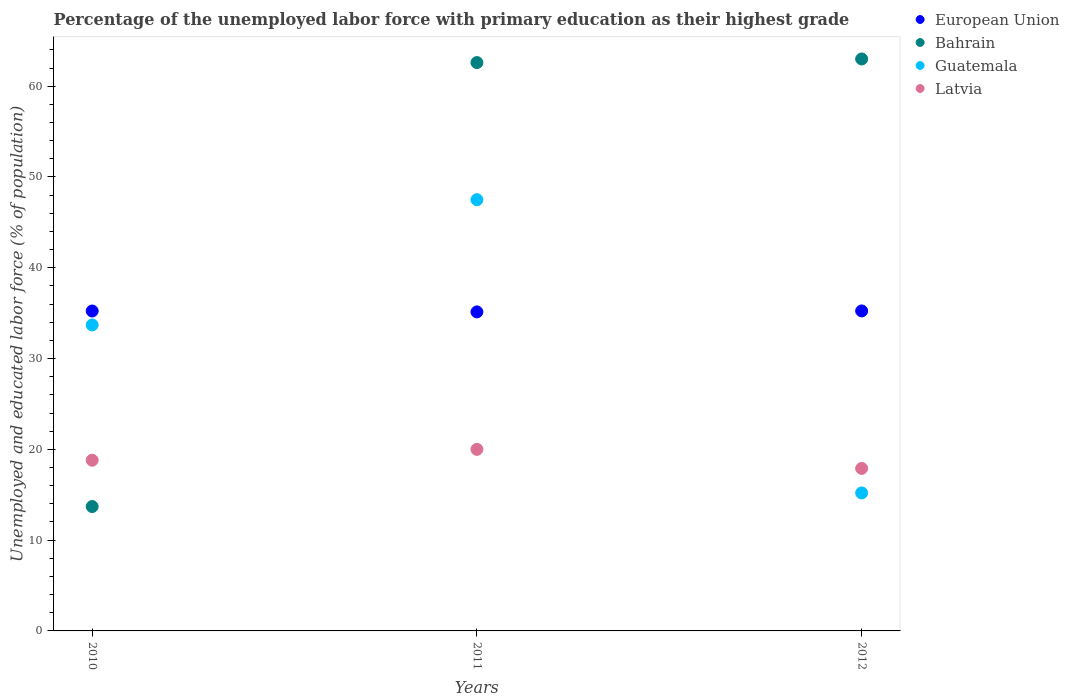Is the number of dotlines equal to the number of legend labels?
Your response must be concise. Yes. Across all years, what is the maximum percentage of the unemployed labor force with primary education in Guatemala?
Keep it short and to the point. 47.5. Across all years, what is the minimum percentage of the unemployed labor force with primary education in Bahrain?
Keep it short and to the point. 13.7. In which year was the percentage of the unemployed labor force with primary education in European Union maximum?
Make the answer very short. 2012. In which year was the percentage of the unemployed labor force with primary education in Latvia minimum?
Provide a succinct answer. 2012. What is the total percentage of the unemployed labor force with primary education in European Union in the graph?
Your answer should be very brief. 105.62. What is the difference between the percentage of the unemployed labor force with primary education in Bahrain in 2010 and that in 2011?
Offer a terse response. -48.9. What is the difference between the percentage of the unemployed labor force with primary education in Guatemala in 2011 and the percentage of the unemployed labor force with primary education in European Union in 2012?
Your answer should be very brief. 12.25. What is the average percentage of the unemployed labor force with primary education in Guatemala per year?
Your answer should be compact. 32.13. In the year 2011, what is the difference between the percentage of the unemployed labor force with primary education in Bahrain and percentage of the unemployed labor force with primary education in Latvia?
Make the answer very short. 42.6. In how many years, is the percentage of the unemployed labor force with primary education in Guatemala greater than 12 %?
Your response must be concise. 3. What is the ratio of the percentage of the unemployed labor force with primary education in Latvia in 2010 to that in 2011?
Your answer should be compact. 0.94. Is the difference between the percentage of the unemployed labor force with primary education in Bahrain in 2011 and 2012 greater than the difference between the percentage of the unemployed labor force with primary education in Latvia in 2011 and 2012?
Provide a succinct answer. No. What is the difference between the highest and the second highest percentage of the unemployed labor force with primary education in Bahrain?
Your answer should be very brief. 0.4. What is the difference between the highest and the lowest percentage of the unemployed labor force with primary education in Guatemala?
Make the answer very short. 32.3. Is the sum of the percentage of the unemployed labor force with primary education in Bahrain in 2011 and 2012 greater than the maximum percentage of the unemployed labor force with primary education in European Union across all years?
Ensure brevity in your answer.  Yes. Is it the case that in every year, the sum of the percentage of the unemployed labor force with primary education in Bahrain and percentage of the unemployed labor force with primary education in European Union  is greater than the percentage of the unemployed labor force with primary education in Guatemala?
Keep it short and to the point. Yes. Is the percentage of the unemployed labor force with primary education in Latvia strictly greater than the percentage of the unemployed labor force with primary education in European Union over the years?
Make the answer very short. No. Is the percentage of the unemployed labor force with primary education in Bahrain strictly less than the percentage of the unemployed labor force with primary education in Guatemala over the years?
Your response must be concise. No. Does the graph contain any zero values?
Make the answer very short. No. How are the legend labels stacked?
Keep it short and to the point. Vertical. What is the title of the graph?
Keep it short and to the point. Percentage of the unemployed labor force with primary education as their highest grade. Does "World" appear as one of the legend labels in the graph?
Offer a terse response. No. What is the label or title of the Y-axis?
Ensure brevity in your answer.  Unemployed and educated labor force (% of population). What is the Unemployed and educated labor force (% of population) of European Union in 2010?
Your response must be concise. 35.24. What is the Unemployed and educated labor force (% of population) in Bahrain in 2010?
Your response must be concise. 13.7. What is the Unemployed and educated labor force (% of population) in Guatemala in 2010?
Offer a terse response. 33.7. What is the Unemployed and educated labor force (% of population) in Latvia in 2010?
Offer a terse response. 18.8. What is the Unemployed and educated labor force (% of population) in European Union in 2011?
Give a very brief answer. 35.14. What is the Unemployed and educated labor force (% of population) in Bahrain in 2011?
Provide a short and direct response. 62.6. What is the Unemployed and educated labor force (% of population) in Guatemala in 2011?
Provide a short and direct response. 47.5. What is the Unemployed and educated labor force (% of population) of European Union in 2012?
Your answer should be very brief. 35.25. What is the Unemployed and educated labor force (% of population) in Bahrain in 2012?
Your answer should be very brief. 63. What is the Unemployed and educated labor force (% of population) of Guatemala in 2012?
Ensure brevity in your answer.  15.2. What is the Unemployed and educated labor force (% of population) in Latvia in 2012?
Make the answer very short. 17.9. Across all years, what is the maximum Unemployed and educated labor force (% of population) of European Union?
Keep it short and to the point. 35.25. Across all years, what is the maximum Unemployed and educated labor force (% of population) in Bahrain?
Provide a succinct answer. 63. Across all years, what is the maximum Unemployed and educated labor force (% of population) in Guatemala?
Keep it short and to the point. 47.5. Across all years, what is the maximum Unemployed and educated labor force (% of population) of Latvia?
Provide a short and direct response. 20. Across all years, what is the minimum Unemployed and educated labor force (% of population) in European Union?
Your answer should be compact. 35.14. Across all years, what is the minimum Unemployed and educated labor force (% of population) of Bahrain?
Provide a succinct answer. 13.7. Across all years, what is the minimum Unemployed and educated labor force (% of population) of Guatemala?
Make the answer very short. 15.2. Across all years, what is the minimum Unemployed and educated labor force (% of population) of Latvia?
Offer a very short reply. 17.9. What is the total Unemployed and educated labor force (% of population) in European Union in the graph?
Ensure brevity in your answer.  105.62. What is the total Unemployed and educated labor force (% of population) in Bahrain in the graph?
Give a very brief answer. 139.3. What is the total Unemployed and educated labor force (% of population) of Guatemala in the graph?
Provide a short and direct response. 96.4. What is the total Unemployed and educated labor force (% of population) in Latvia in the graph?
Your answer should be compact. 56.7. What is the difference between the Unemployed and educated labor force (% of population) of European Union in 2010 and that in 2011?
Your response must be concise. 0.1. What is the difference between the Unemployed and educated labor force (% of population) in Bahrain in 2010 and that in 2011?
Your answer should be very brief. -48.9. What is the difference between the Unemployed and educated labor force (% of population) of European Union in 2010 and that in 2012?
Provide a short and direct response. -0.01. What is the difference between the Unemployed and educated labor force (% of population) in Bahrain in 2010 and that in 2012?
Make the answer very short. -49.3. What is the difference between the Unemployed and educated labor force (% of population) of Guatemala in 2010 and that in 2012?
Provide a succinct answer. 18.5. What is the difference between the Unemployed and educated labor force (% of population) in European Union in 2011 and that in 2012?
Your answer should be compact. -0.11. What is the difference between the Unemployed and educated labor force (% of population) in Bahrain in 2011 and that in 2012?
Provide a succinct answer. -0.4. What is the difference between the Unemployed and educated labor force (% of population) of Guatemala in 2011 and that in 2012?
Offer a terse response. 32.3. What is the difference between the Unemployed and educated labor force (% of population) of Latvia in 2011 and that in 2012?
Ensure brevity in your answer.  2.1. What is the difference between the Unemployed and educated labor force (% of population) of European Union in 2010 and the Unemployed and educated labor force (% of population) of Bahrain in 2011?
Keep it short and to the point. -27.36. What is the difference between the Unemployed and educated labor force (% of population) of European Union in 2010 and the Unemployed and educated labor force (% of population) of Guatemala in 2011?
Make the answer very short. -12.26. What is the difference between the Unemployed and educated labor force (% of population) of European Union in 2010 and the Unemployed and educated labor force (% of population) of Latvia in 2011?
Provide a short and direct response. 15.24. What is the difference between the Unemployed and educated labor force (% of population) of Bahrain in 2010 and the Unemployed and educated labor force (% of population) of Guatemala in 2011?
Offer a very short reply. -33.8. What is the difference between the Unemployed and educated labor force (% of population) of European Union in 2010 and the Unemployed and educated labor force (% of population) of Bahrain in 2012?
Keep it short and to the point. -27.76. What is the difference between the Unemployed and educated labor force (% of population) in European Union in 2010 and the Unemployed and educated labor force (% of population) in Guatemala in 2012?
Your answer should be very brief. 20.04. What is the difference between the Unemployed and educated labor force (% of population) in European Union in 2010 and the Unemployed and educated labor force (% of population) in Latvia in 2012?
Provide a short and direct response. 17.34. What is the difference between the Unemployed and educated labor force (% of population) of Guatemala in 2010 and the Unemployed and educated labor force (% of population) of Latvia in 2012?
Your answer should be very brief. 15.8. What is the difference between the Unemployed and educated labor force (% of population) of European Union in 2011 and the Unemployed and educated labor force (% of population) of Bahrain in 2012?
Give a very brief answer. -27.86. What is the difference between the Unemployed and educated labor force (% of population) of European Union in 2011 and the Unemployed and educated labor force (% of population) of Guatemala in 2012?
Give a very brief answer. 19.94. What is the difference between the Unemployed and educated labor force (% of population) of European Union in 2011 and the Unemployed and educated labor force (% of population) of Latvia in 2012?
Your answer should be compact. 17.24. What is the difference between the Unemployed and educated labor force (% of population) of Bahrain in 2011 and the Unemployed and educated labor force (% of population) of Guatemala in 2012?
Offer a terse response. 47.4. What is the difference between the Unemployed and educated labor force (% of population) in Bahrain in 2011 and the Unemployed and educated labor force (% of population) in Latvia in 2012?
Ensure brevity in your answer.  44.7. What is the difference between the Unemployed and educated labor force (% of population) in Guatemala in 2011 and the Unemployed and educated labor force (% of population) in Latvia in 2012?
Make the answer very short. 29.6. What is the average Unemployed and educated labor force (% of population) in European Union per year?
Make the answer very short. 35.21. What is the average Unemployed and educated labor force (% of population) in Bahrain per year?
Provide a short and direct response. 46.43. What is the average Unemployed and educated labor force (% of population) of Guatemala per year?
Give a very brief answer. 32.13. In the year 2010, what is the difference between the Unemployed and educated labor force (% of population) of European Union and Unemployed and educated labor force (% of population) of Bahrain?
Offer a very short reply. 21.54. In the year 2010, what is the difference between the Unemployed and educated labor force (% of population) in European Union and Unemployed and educated labor force (% of population) in Guatemala?
Make the answer very short. 1.54. In the year 2010, what is the difference between the Unemployed and educated labor force (% of population) of European Union and Unemployed and educated labor force (% of population) of Latvia?
Your answer should be very brief. 16.44. In the year 2010, what is the difference between the Unemployed and educated labor force (% of population) of Bahrain and Unemployed and educated labor force (% of population) of Guatemala?
Provide a succinct answer. -20. In the year 2010, what is the difference between the Unemployed and educated labor force (% of population) in Bahrain and Unemployed and educated labor force (% of population) in Latvia?
Provide a succinct answer. -5.1. In the year 2010, what is the difference between the Unemployed and educated labor force (% of population) in Guatemala and Unemployed and educated labor force (% of population) in Latvia?
Your answer should be compact. 14.9. In the year 2011, what is the difference between the Unemployed and educated labor force (% of population) of European Union and Unemployed and educated labor force (% of population) of Bahrain?
Your response must be concise. -27.46. In the year 2011, what is the difference between the Unemployed and educated labor force (% of population) of European Union and Unemployed and educated labor force (% of population) of Guatemala?
Provide a succinct answer. -12.36. In the year 2011, what is the difference between the Unemployed and educated labor force (% of population) of European Union and Unemployed and educated labor force (% of population) of Latvia?
Keep it short and to the point. 15.14. In the year 2011, what is the difference between the Unemployed and educated labor force (% of population) in Bahrain and Unemployed and educated labor force (% of population) in Latvia?
Make the answer very short. 42.6. In the year 2012, what is the difference between the Unemployed and educated labor force (% of population) in European Union and Unemployed and educated labor force (% of population) in Bahrain?
Offer a terse response. -27.75. In the year 2012, what is the difference between the Unemployed and educated labor force (% of population) in European Union and Unemployed and educated labor force (% of population) in Guatemala?
Provide a succinct answer. 20.05. In the year 2012, what is the difference between the Unemployed and educated labor force (% of population) in European Union and Unemployed and educated labor force (% of population) in Latvia?
Ensure brevity in your answer.  17.35. In the year 2012, what is the difference between the Unemployed and educated labor force (% of population) in Bahrain and Unemployed and educated labor force (% of population) in Guatemala?
Offer a very short reply. 47.8. In the year 2012, what is the difference between the Unemployed and educated labor force (% of population) in Bahrain and Unemployed and educated labor force (% of population) in Latvia?
Make the answer very short. 45.1. In the year 2012, what is the difference between the Unemployed and educated labor force (% of population) in Guatemala and Unemployed and educated labor force (% of population) in Latvia?
Make the answer very short. -2.7. What is the ratio of the Unemployed and educated labor force (% of population) in European Union in 2010 to that in 2011?
Your answer should be compact. 1. What is the ratio of the Unemployed and educated labor force (% of population) of Bahrain in 2010 to that in 2011?
Offer a terse response. 0.22. What is the ratio of the Unemployed and educated labor force (% of population) in Guatemala in 2010 to that in 2011?
Your answer should be very brief. 0.71. What is the ratio of the Unemployed and educated labor force (% of population) of European Union in 2010 to that in 2012?
Your answer should be compact. 1. What is the ratio of the Unemployed and educated labor force (% of population) of Bahrain in 2010 to that in 2012?
Ensure brevity in your answer.  0.22. What is the ratio of the Unemployed and educated labor force (% of population) of Guatemala in 2010 to that in 2012?
Your answer should be very brief. 2.22. What is the ratio of the Unemployed and educated labor force (% of population) of Latvia in 2010 to that in 2012?
Keep it short and to the point. 1.05. What is the ratio of the Unemployed and educated labor force (% of population) in Guatemala in 2011 to that in 2012?
Your answer should be very brief. 3.12. What is the ratio of the Unemployed and educated labor force (% of population) in Latvia in 2011 to that in 2012?
Your answer should be very brief. 1.12. What is the difference between the highest and the second highest Unemployed and educated labor force (% of population) of European Union?
Ensure brevity in your answer.  0.01. What is the difference between the highest and the second highest Unemployed and educated labor force (% of population) in Guatemala?
Offer a terse response. 13.8. What is the difference between the highest and the second highest Unemployed and educated labor force (% of population) of Latvia?
Your answer should be compact. 1.2. What is the difference between the highest and the lowest Unemployed and educated labor force (% of population) of European Union?
Offer a very short reply. 0.11. What is the difference between the highest and the lowest Unemployed and educated labor force (% of population) of Bahrain?
Ensure brevity in your answer.  49.3. What is the difference between the highest and the lowest Unemployed and educated labor force (% of population) of Guatemala?
Ensure brevity in your answer.  32.3. 